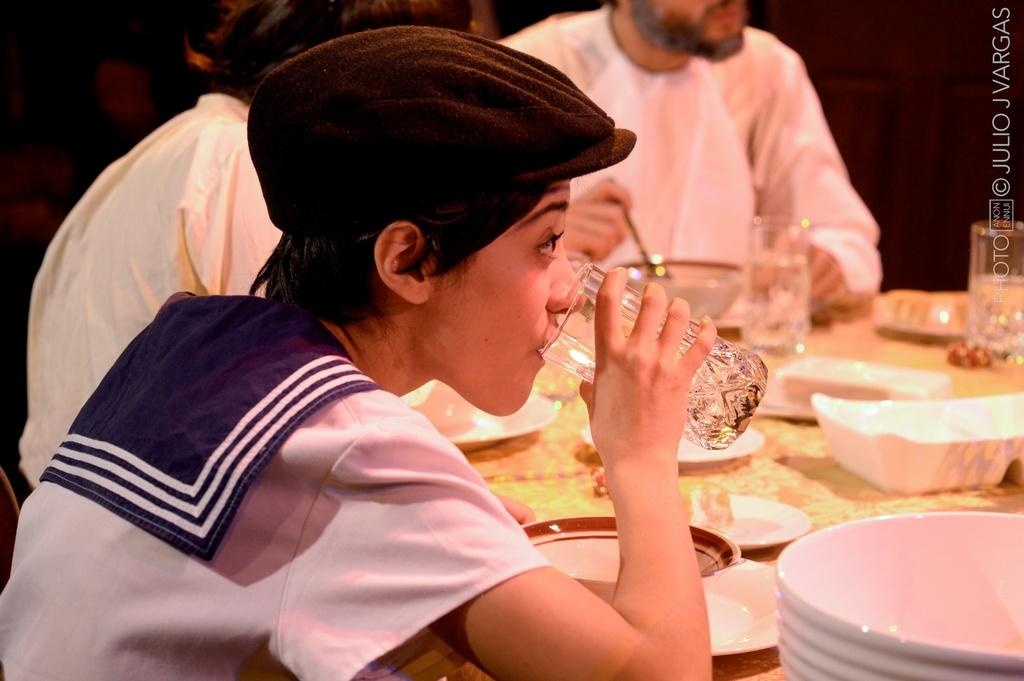How many people are in the image? There are three persons in the image. What is present on the table in the image? There is a plate and a glass on the table. What is the person holding in the image? One person is holding a glass. What is the person holding the glass drinking? The person holding the glass is drinking water. What type of bone can be seen in the image? There is no bone present in the image. What hobbies do the people in the image have? The provided facts do not give information about the hobbies of the people in the image. 